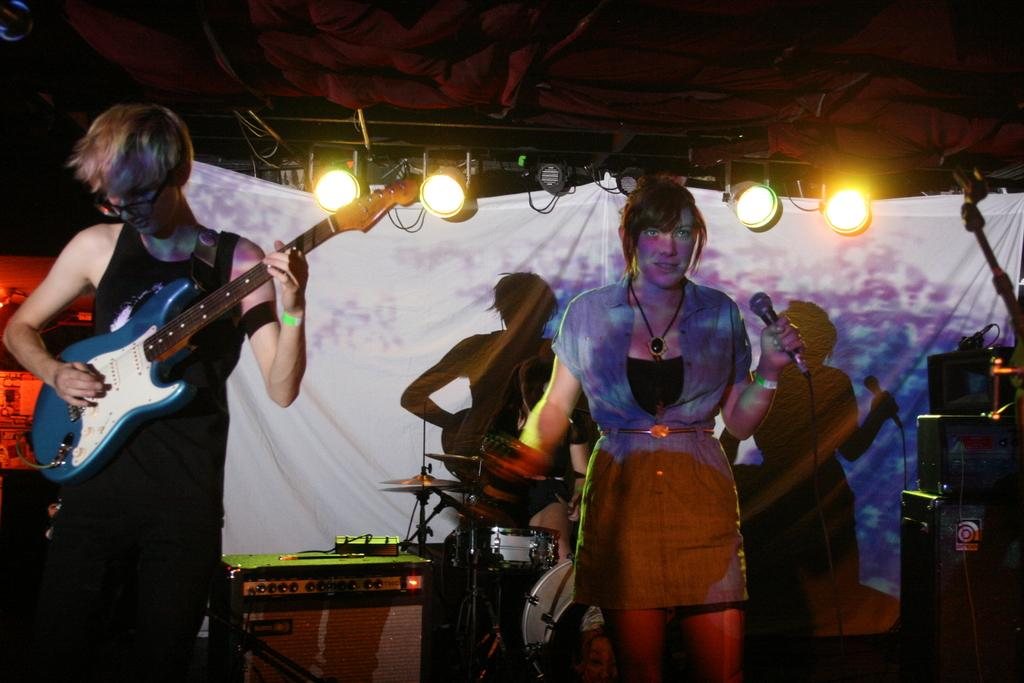What is the person in the image doing? The person is playing a guitar. Can you describe the person's appearance? The person is wearing spectacles. What additional elements can be seen in the image? There are focusing lights visible, a woman holding a microphone, musical instruments, and speakers. How many geese are present in the image? There are no geese present in the image. What type of underwear is the person wearing in the image? The person's clothing, including any underwear, is not visible in the image. 